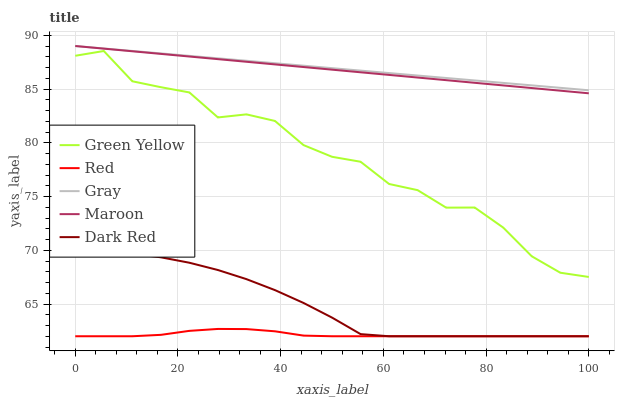Does Red have the minimum area under the curve?
Answer yes or no. Yes. Does Gray have the maximum area under the curve?
Answer yes or no. Yes. Does Green Yellow have the minimum area under the curve?
Answer yes or no. No. Does Green Yellow have the maximum area under the curve?
Answer yes or no. No. Is Maroon the smoothest?
Answer yes or no. Yes. Is Green Yellow the roughest?
Answer yes or no. Yes. Is Green Yellow the smoothest?
Answer yes or no. No. Is Maroon the roughest?
Answer yes or no. No. Does Red have the lowest value?
Answer yes or no. Yes. Does Green Yellow have the lowest value?
Answer yes or no. No. Does Maroon have the highest value?
Answer yes or no. Yes. Does Green Yellow have the highest value?
Answer yes or no. No. Is Dark Red less than Maroon?
Answer yes or no. Yes. Is Green Yellow greater than Dark Red?
Answer yes or no. Yes. Does Maroon intersect Gray?
Answer yes or no. Yes. Is Maroon less than Gray?
Answer yes or no. No. Is Maroon greater than Gray?
Answer yes or no. No. Does Dark Red intersect Maroon?
Answer yes or no. No. 